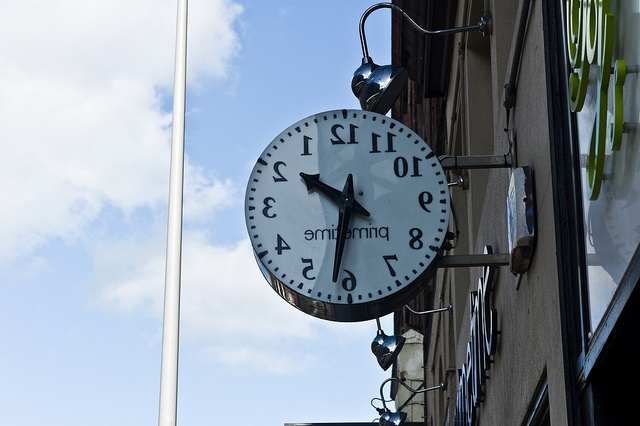Describe the objects in this image and their specific colors. I can see a clock in white, gray, darkgray, and black tones in this image. 